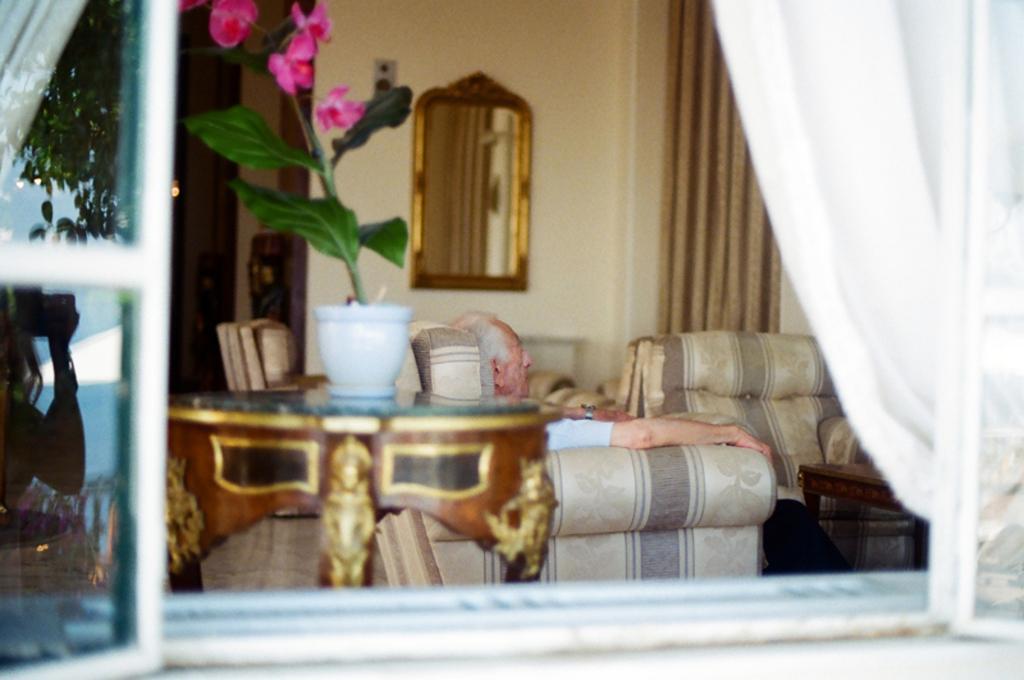In one or two sentences, can you explain what this image depicts? In this image I can see few sofas, a plant and a mirror on this wall. 